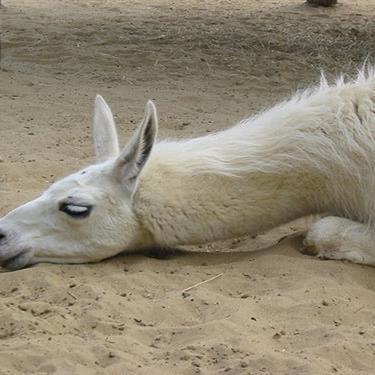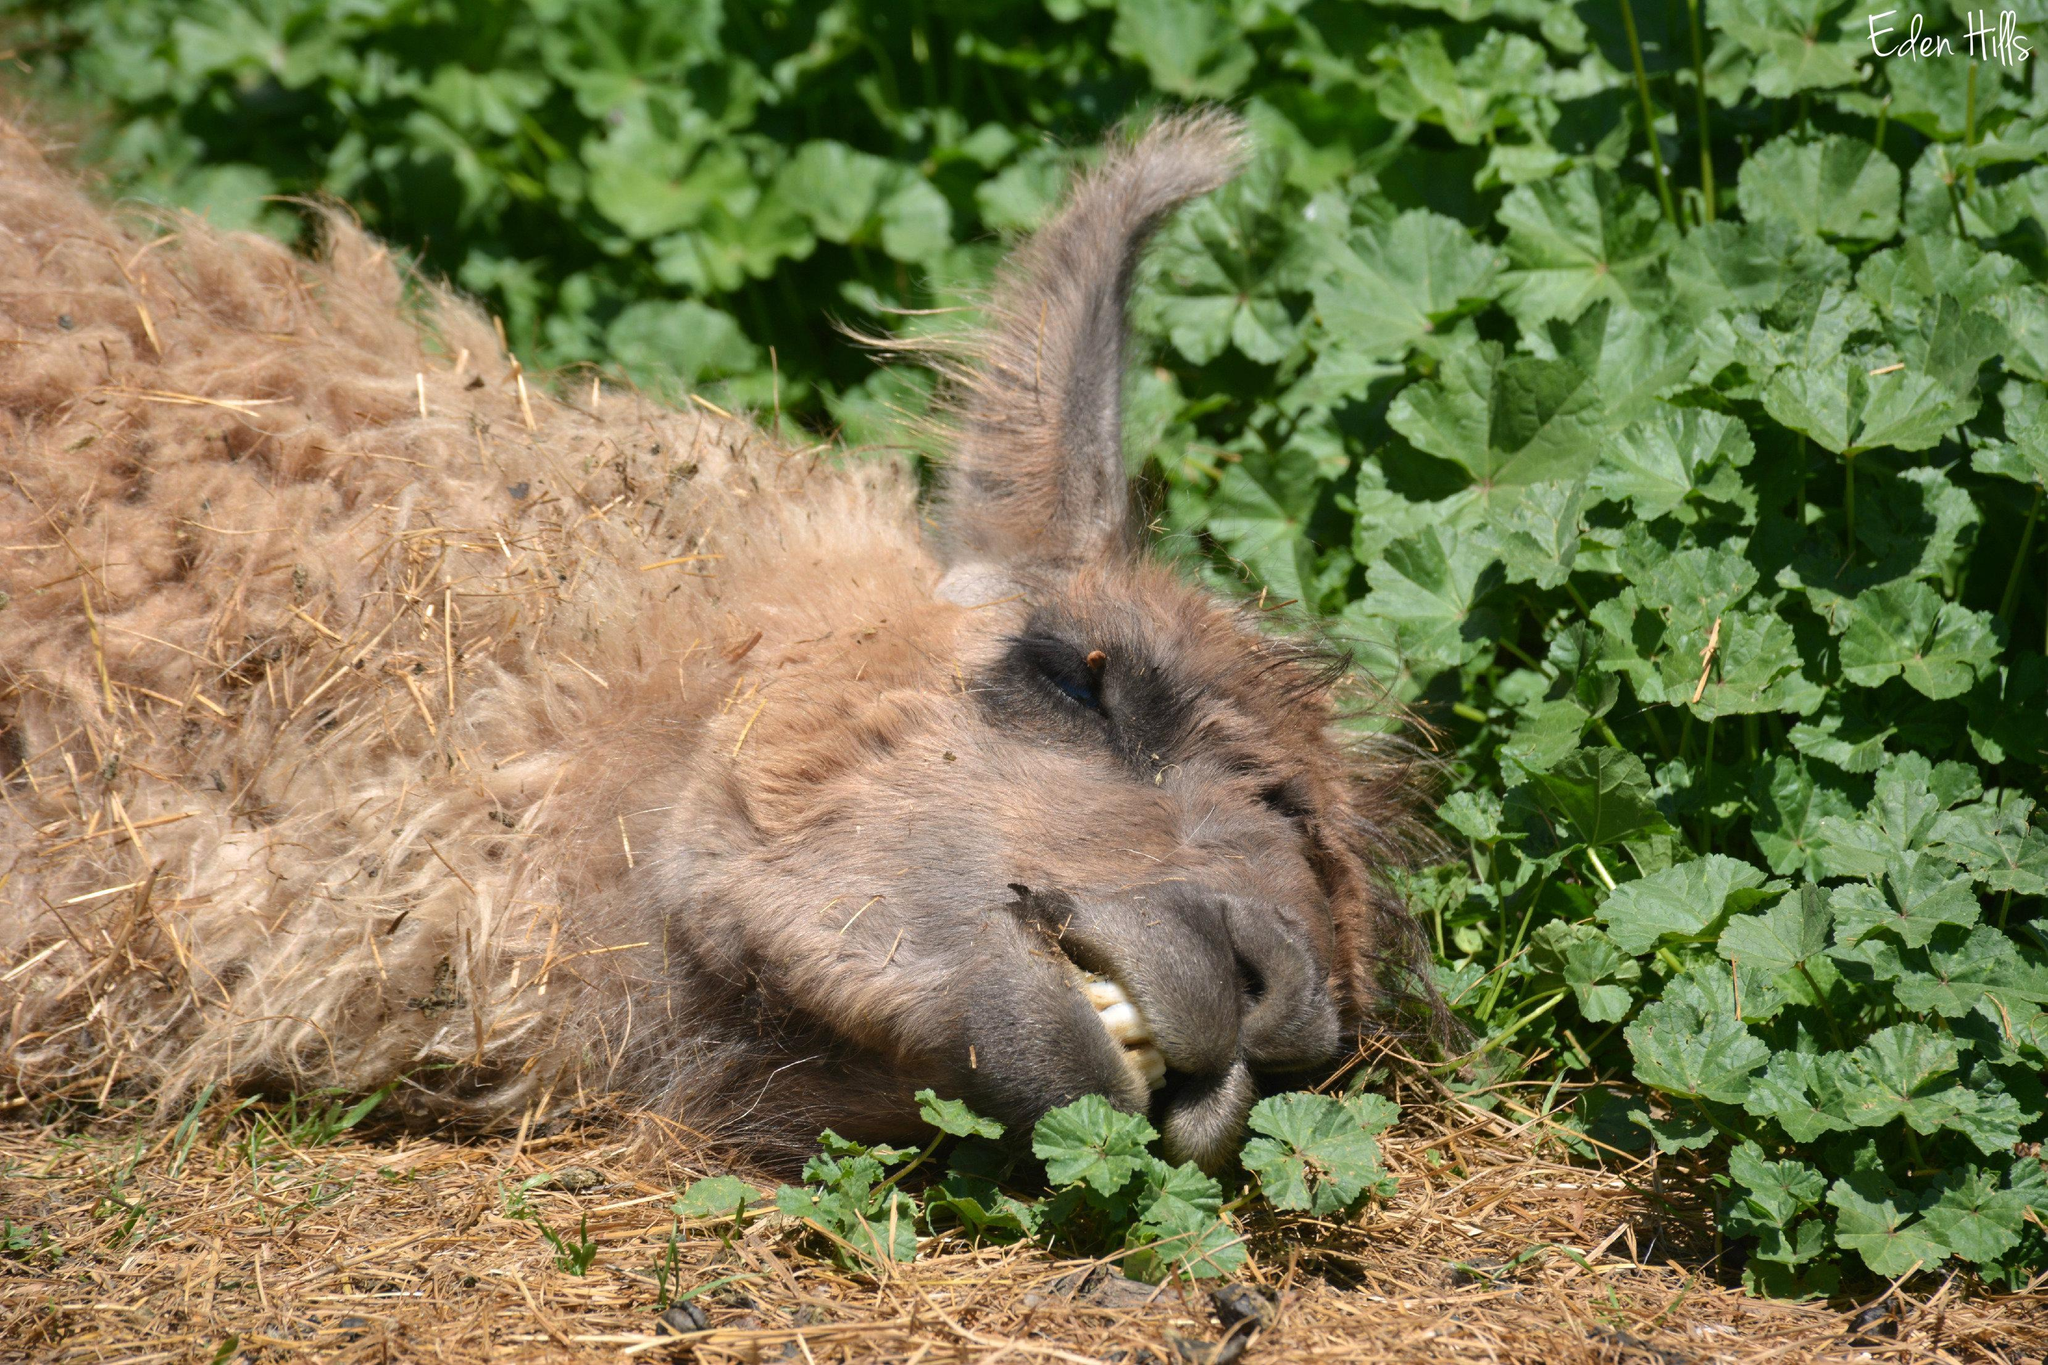The first image is the image on the left, the second image is the image on the right. Evaluate the accuracy of this statement regarding the images: "All llamas are lying on the ground, and at least one llama is lying with the side of its head on the ground.". Is it true? Answer yes or no. Yes. The first image is the image on the left, the second image is the image on the right. Assess this claim about the two images: "There are two llamas in one image and one llama in the other.". Correct or not? Answer yes or no. No. 